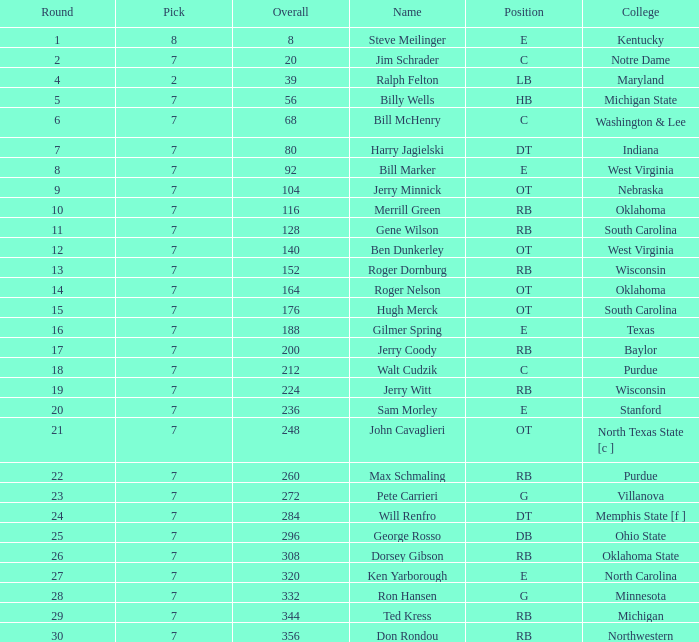What round did ron hansen get drafted in, given that the overall pick was higher than 332? 0.0. 